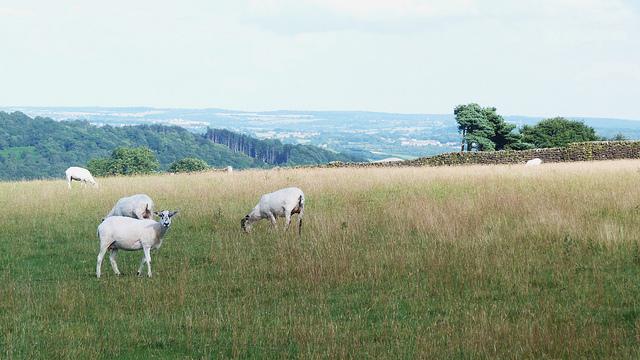How many sheepskin are grazing?
Give a very brief answer. 4. Have the adult sheep been sheared?
Short answer required. Yes. Is there a Wal-Mart within a mile of this place?
Be succinct. No. How many animals are in the picture?
Be succinct. 6. Is this taken at high elevation?
Keep it brief. Yes. How many animals are in the photo?
Be succinct. 5. 